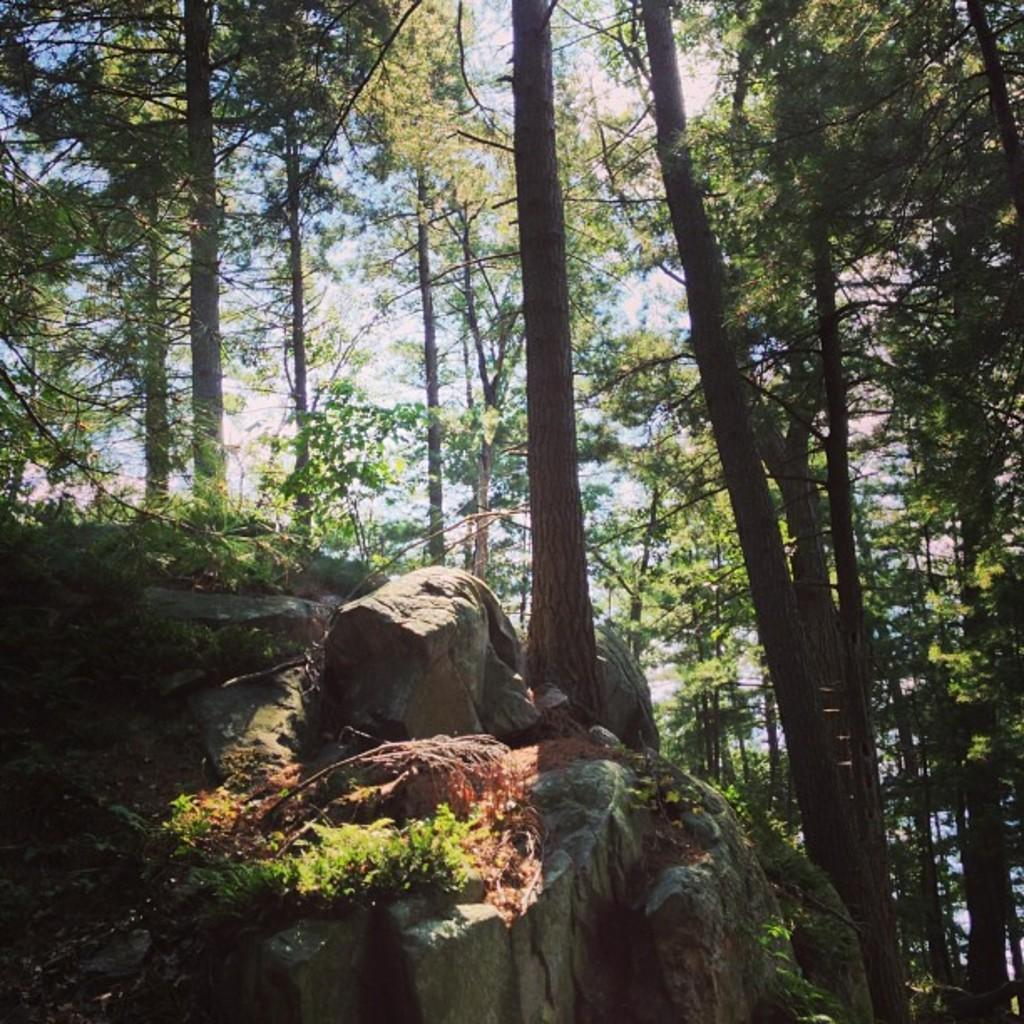What type of vegetation is present in the image? There are many trees in the image. What other natural elements can be seen in the image? There are rocks and grass visible in the image. What is visible in the background of the image? The sky is visible in the image. Where is the library located in the image? There is no library present in the image. Is there a crook in the image? There is no crook present in the image. Can you see a kitten playing in the grass in the image? There is no kitten present in the image. 